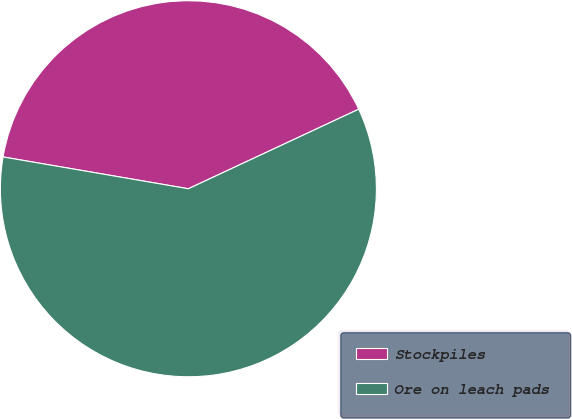Convert chart. <chart><loc_0><loc_0><loc_500><loc_500><pie_chart><fcel>Stockpiles<fcel>Ore on leach pads<nl><fcel>40.34%<fcel>59.66%<nl></chart> 